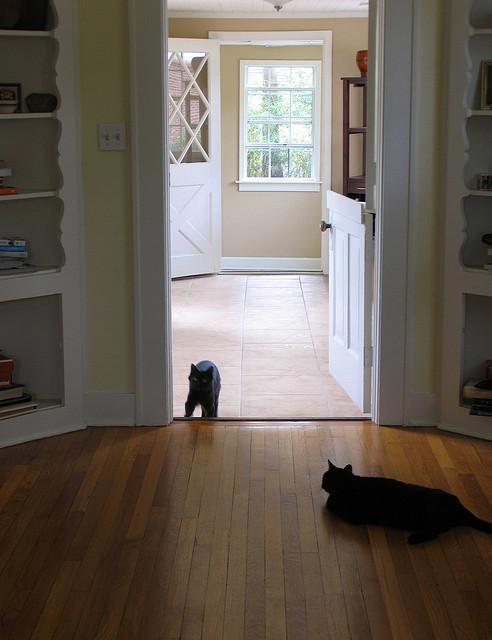How many people in the boat?
Give a very brief answer. 0. 